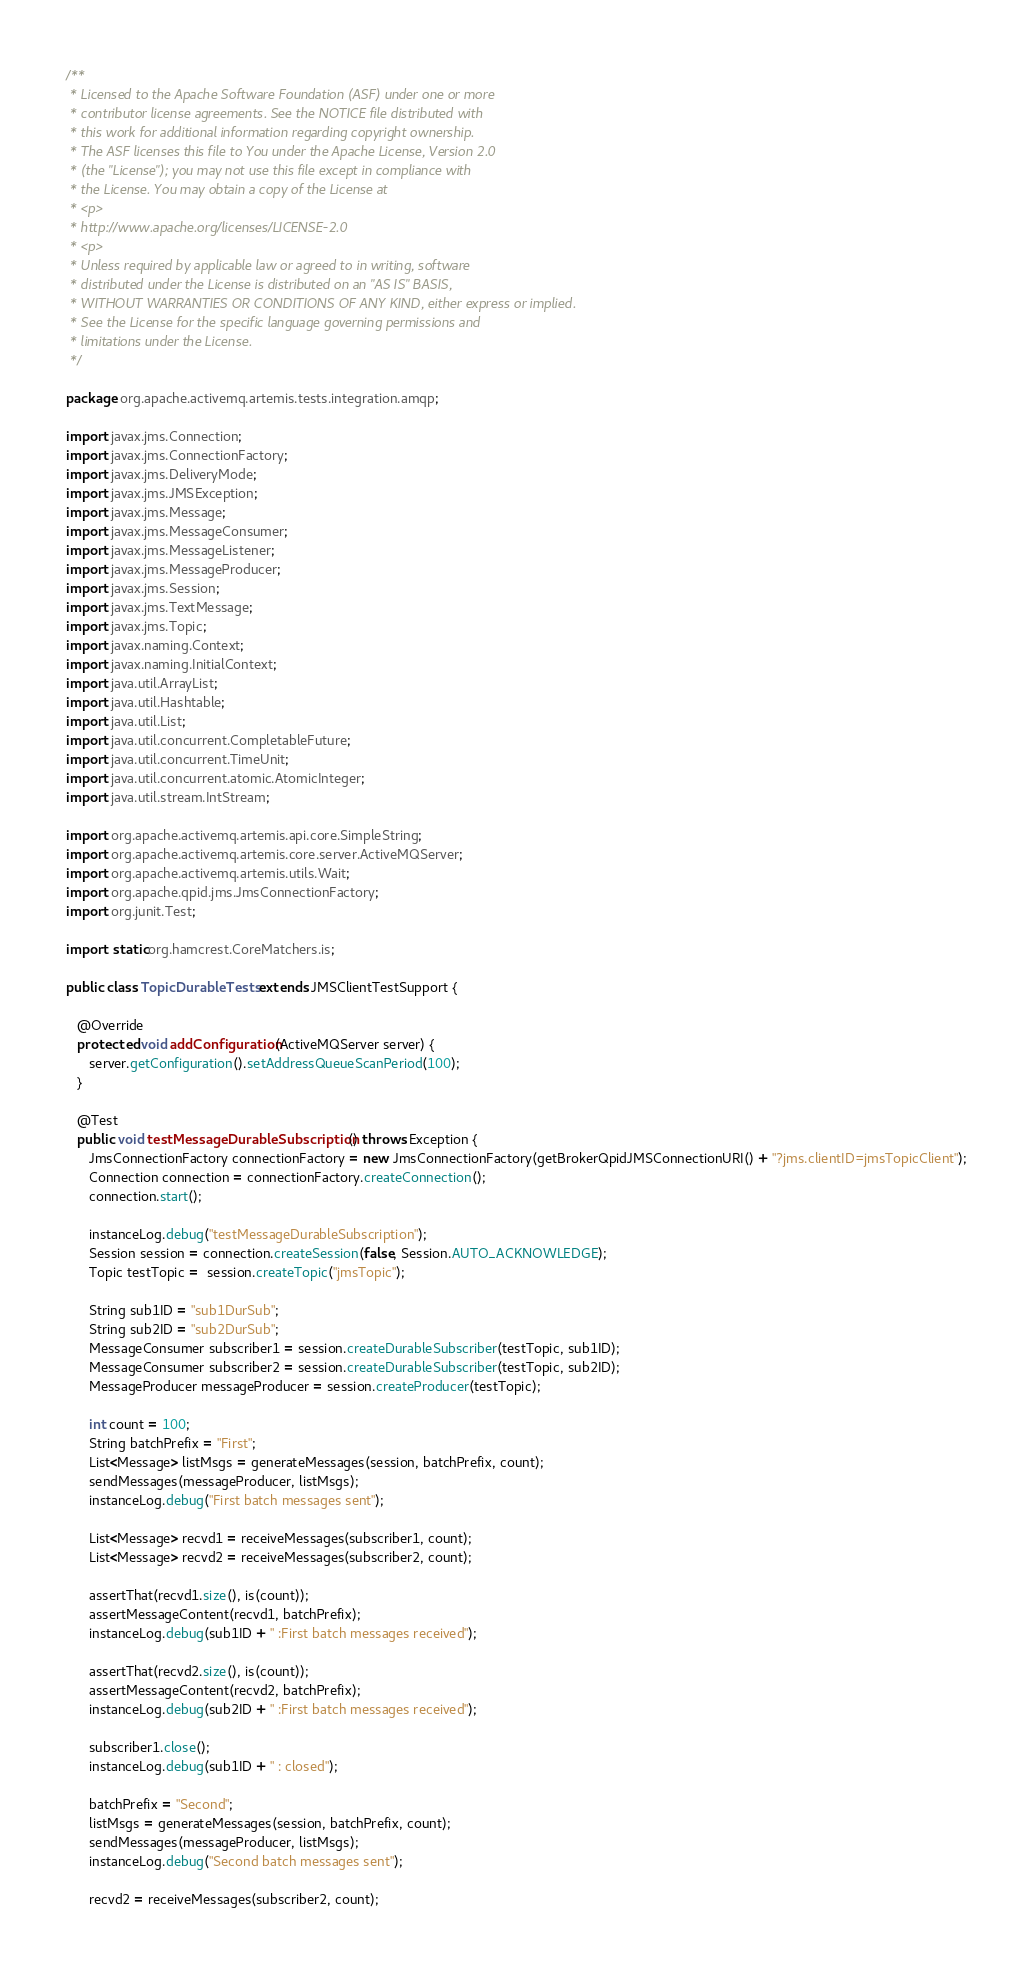Convert code to text. <code><loc_0><loc_0><loc_500><loc_500><_Java_>/**
 * Licensed to the Apache Software Foundation (ASF) under one or more
 * contributor license agreements. See the NOTICE file distributed with
 * this work for additional information regarding copyright ownership.
 * The ASF licenses this file to You under the Apache License, Version 2.0
 * (the "License"); you may not use this file except in compliance with
 * the License. You may obtain a copy of the License at
 * <p>
 * http://www.apache.org/licenses/LICENSE-2.0
 * <p>
 * Unless required by applicable law or agreed to in writing, software
 * distributed under the License is distributed on an "AS IS" BASIS,
 * WITHOUT WARRANTIES OR CONDITIONS OF ANY KIND, either express or implied.
 * See the License for the specific language governing permissions and
 * limitations under the License.
 */

package org.apache.activemq.artemis.tests.integration.amqp;

import javax.jms.Connection;
import javax.jms.ConnectionFactory;
import javax.jms.DeliveryMode;
import javax.jms.JMSException;
import javax.jms.Message;
import javax.jms.MessageConsumer;
import javax.jms.MessageListener;
import javax.jms.MessageProducer;
import javax.jms.Session;
import javax.jms.TextMessage;
import javax.jms.Topic;
import javax.naming.Context;
import javax.naming.InitialContext;
import java.util.ArrayList;
import java.util.Hashtable;
import java.util.List;
import java.util.concurrent.CompletableFuture;
import java.util.concurrent.TimeUnit;
import java.util.concurrent.atomic.AtomicInteger;
import java.util.stream.IntStream;

import org.apache.activemq.artemis.api.core.SimpleString;
import org.apache.activemq.artemis.core.server.ActiveMQServer;
import org.apache.activemq.artemis.utils.Wait;
import org.apache.qpid.jms.JmsConnectionFactory;
import org.junit.Test;

import static org.hamcrest.CoreMatchers.is;

public class TopicDurableTests extends JMSClientTestSupport {

   @Override
   protected void addConfiguration(ActiveMQServer server) {
      server.getConfiguration().setAddressQueueScanPeriod(100);
   }

   @Test
   public void testMessageDurableSubscription() throws Exception {
      JmsConnectionFactory connectionFactory = new JmsConnectionFactory(getBrokerQpidJMSConnectionURI() + "?jms.clientID=jmsTopicClient");
      Connection connection = connectionFactory.createConnection();
      connection.start();

      instanceLog.debug("testMessageDurableSubscription");
      Session session = connection.createSession(false, Session.AUTO_ACKNOWLEDGE);
      Topic testTopic =  session.createTopic("jmsTopic");

      String sub1ID = "sub1DurSub";
      String sub2ID = "sub2DurSub";
      MessageConsumer subscriber1 = session.createDurableSubscriber(testTopic, sub1ID);
      MessageConsumer subscriber2 = session.createDurableSubscriber(testTopic, sub2ID);
      MessageProducer messageProducer = session.createProducer(testTopic);

      int count = 100;
      String batchPrefix = "First";
      List<Message> listMsgs = generateMessages(session, batchPrefix, count);
      sendMessages(messageProducer, listMsgs);
      instanceLog.debug("First batch messages sent");

      List<Message> recvd1 = receiveMessages(subscriber1, count);
      List<Message> recvd2 = receiveMessages(subscriber2, count);

      assertThat(recvd1.size(), is(count));
      assertMessageContent(recvd1, batchPrefix);
      instanceLog.debug(sub1ID + " :First batch messages received");

      assertThat(recvd2.size(), is(count));
      assertMessageContent(recvd2, batchPrefix);
      instanceLog.debug(sub2ID + " :First batch messages received");

      subscriber1.close();
      instanceLog.debug(sub1ID + " : closed");

      batchPrefix = "Second";
      listMsgs = generateMessages(session, batchPrefix, count);
      sendMessages(messageProducer, listMsgs);
      instanceLog.debug("Second batch messages sent");

      recvd2 = receiveMessages(subscriber2, count);</code> 